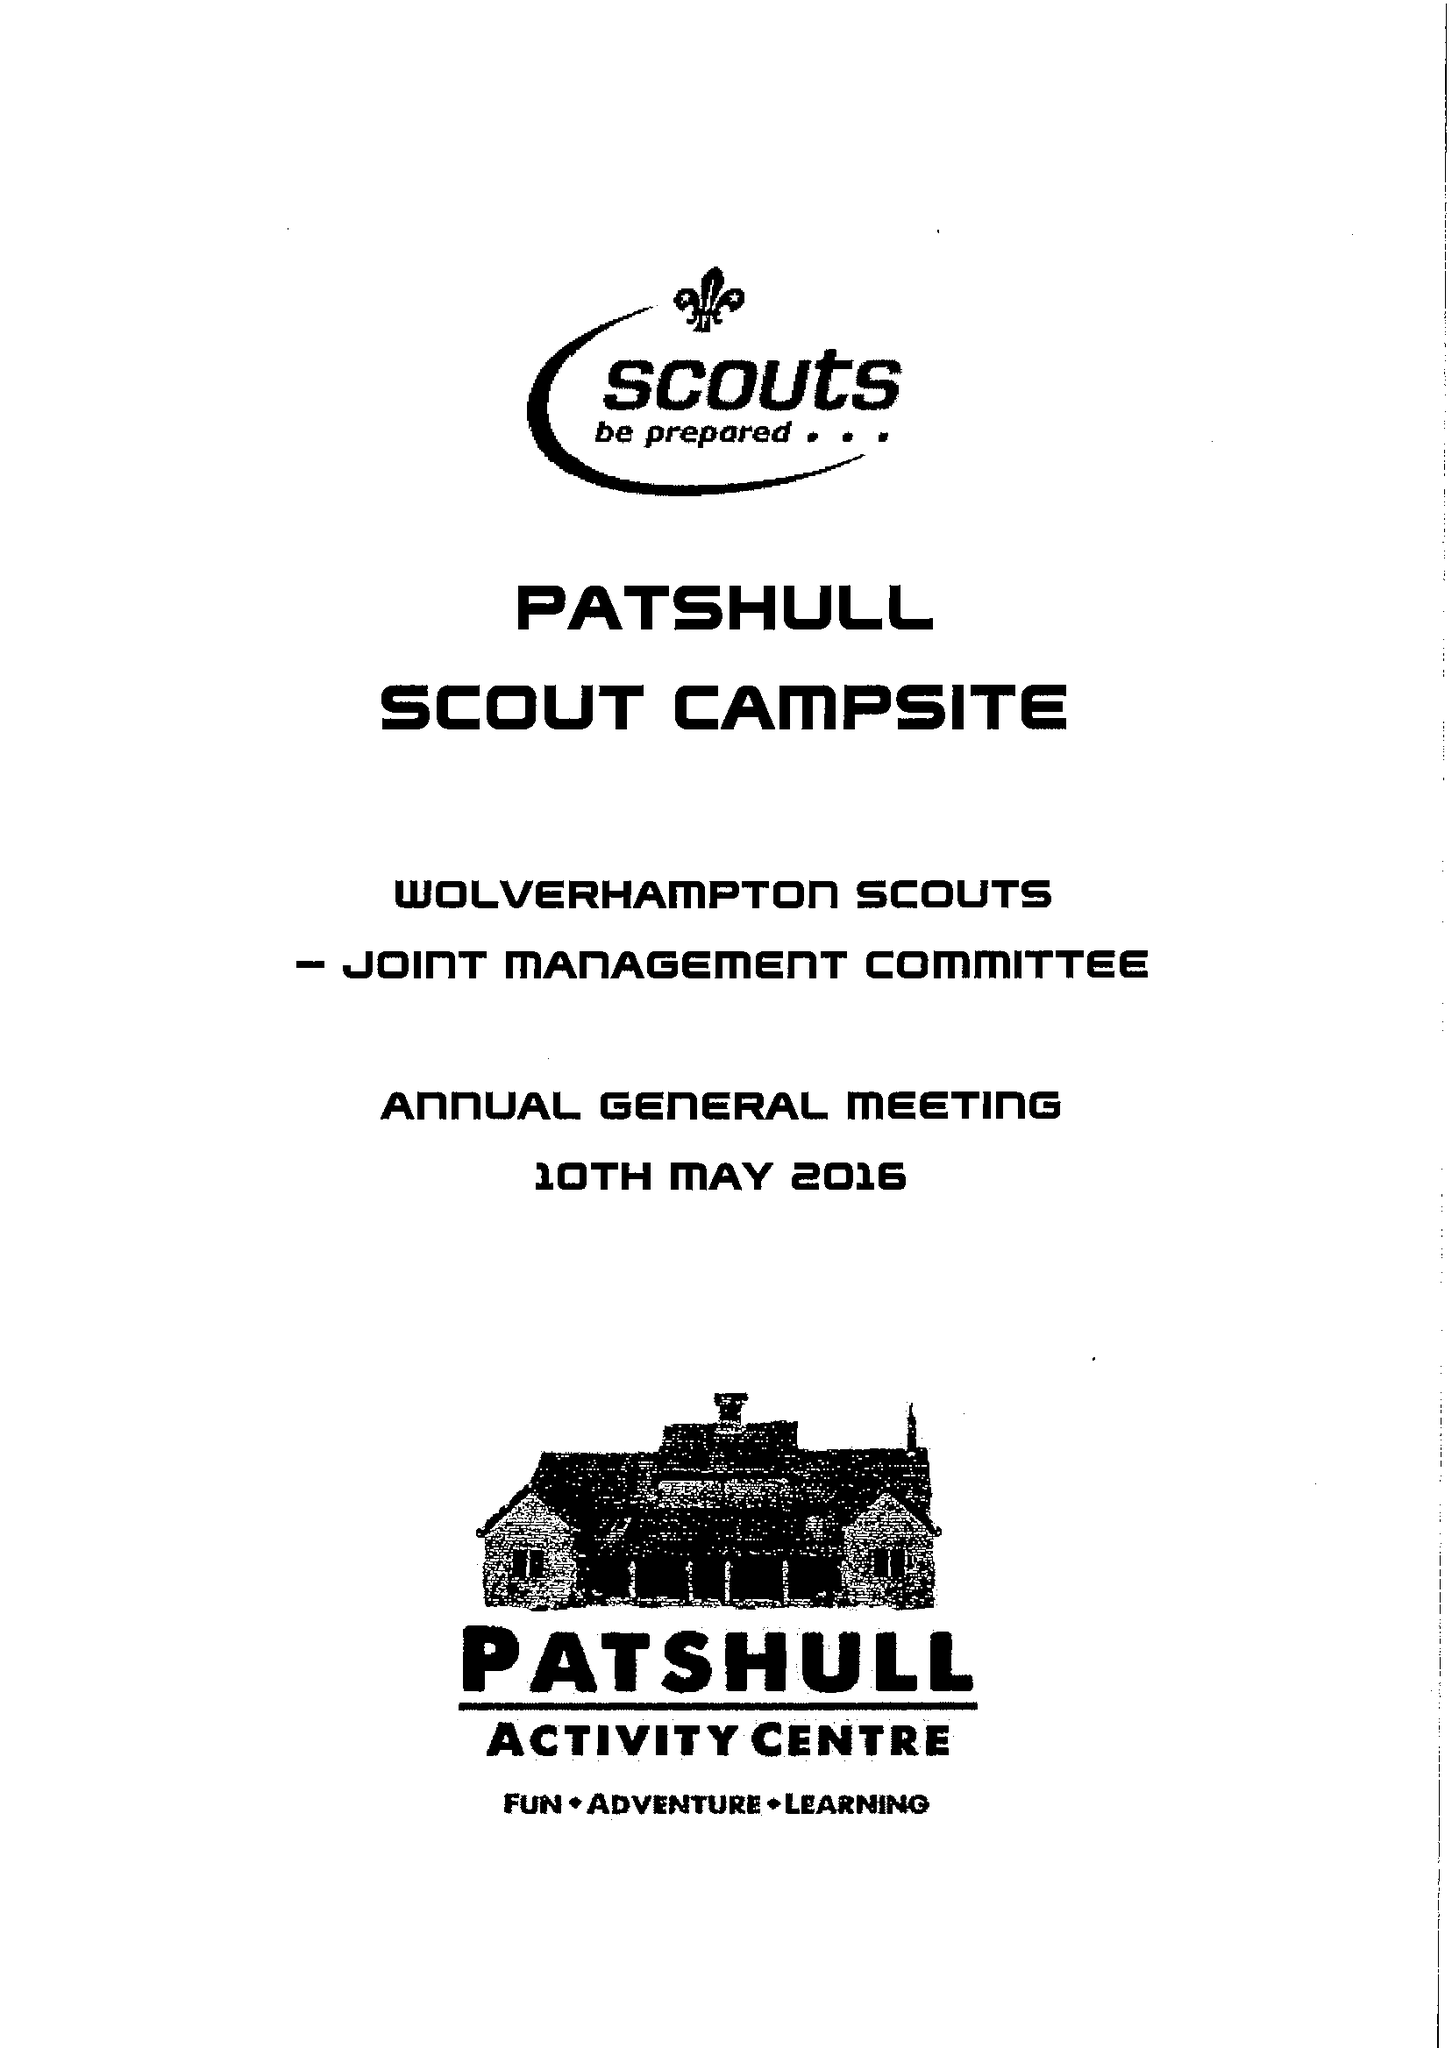What is the value for the spending_annually_in_british_pounds?
Answer the question using a single word or phrase. 22503.00 